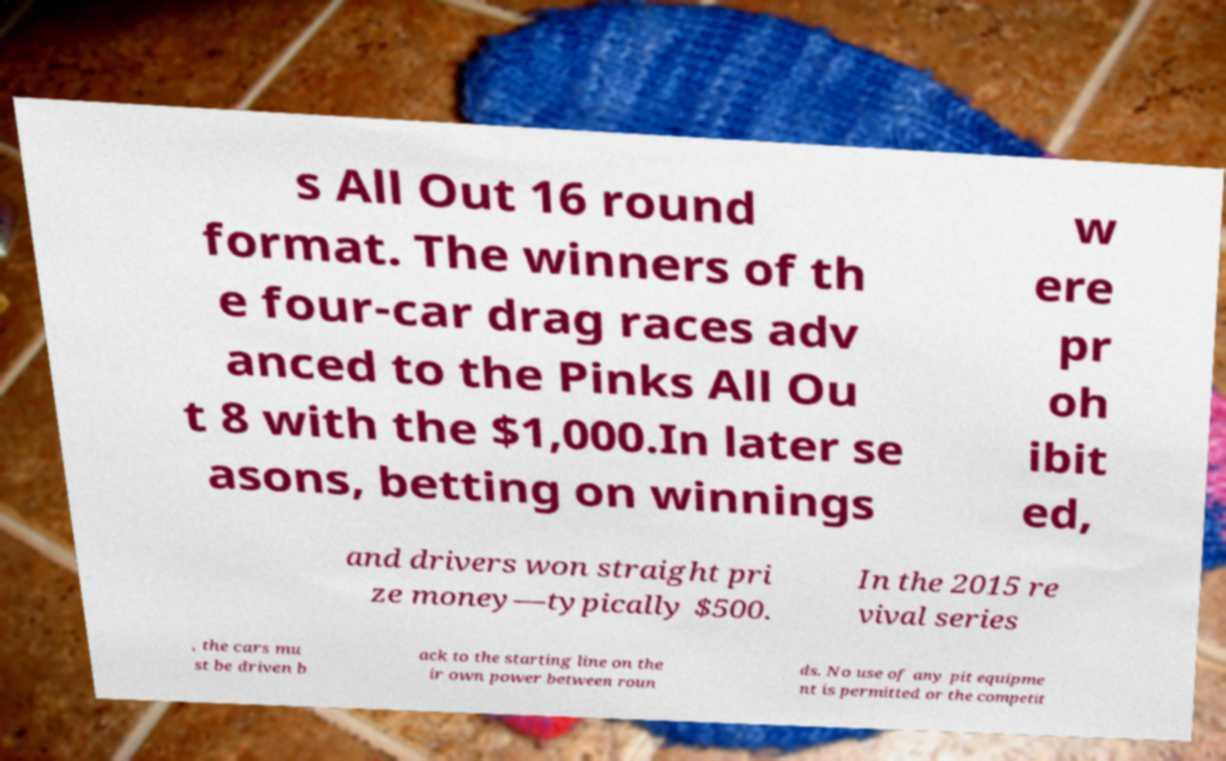I need the written content from this picture converted into text. Can you do that? s All Out 16 round format. The winners of th e four-car drag races adv anced to the Pinks All Ou t 8 with the $1,000.In later se asons, betting on winnings w ere pr oh ibit ed, and drivers won straight pri ze money—typically $500. In the 2015 re vival series , the cars mu st be driven b ack to the starting line on the ir own power between roun ds. No use of any pit equipme nt is permitted or the competit 